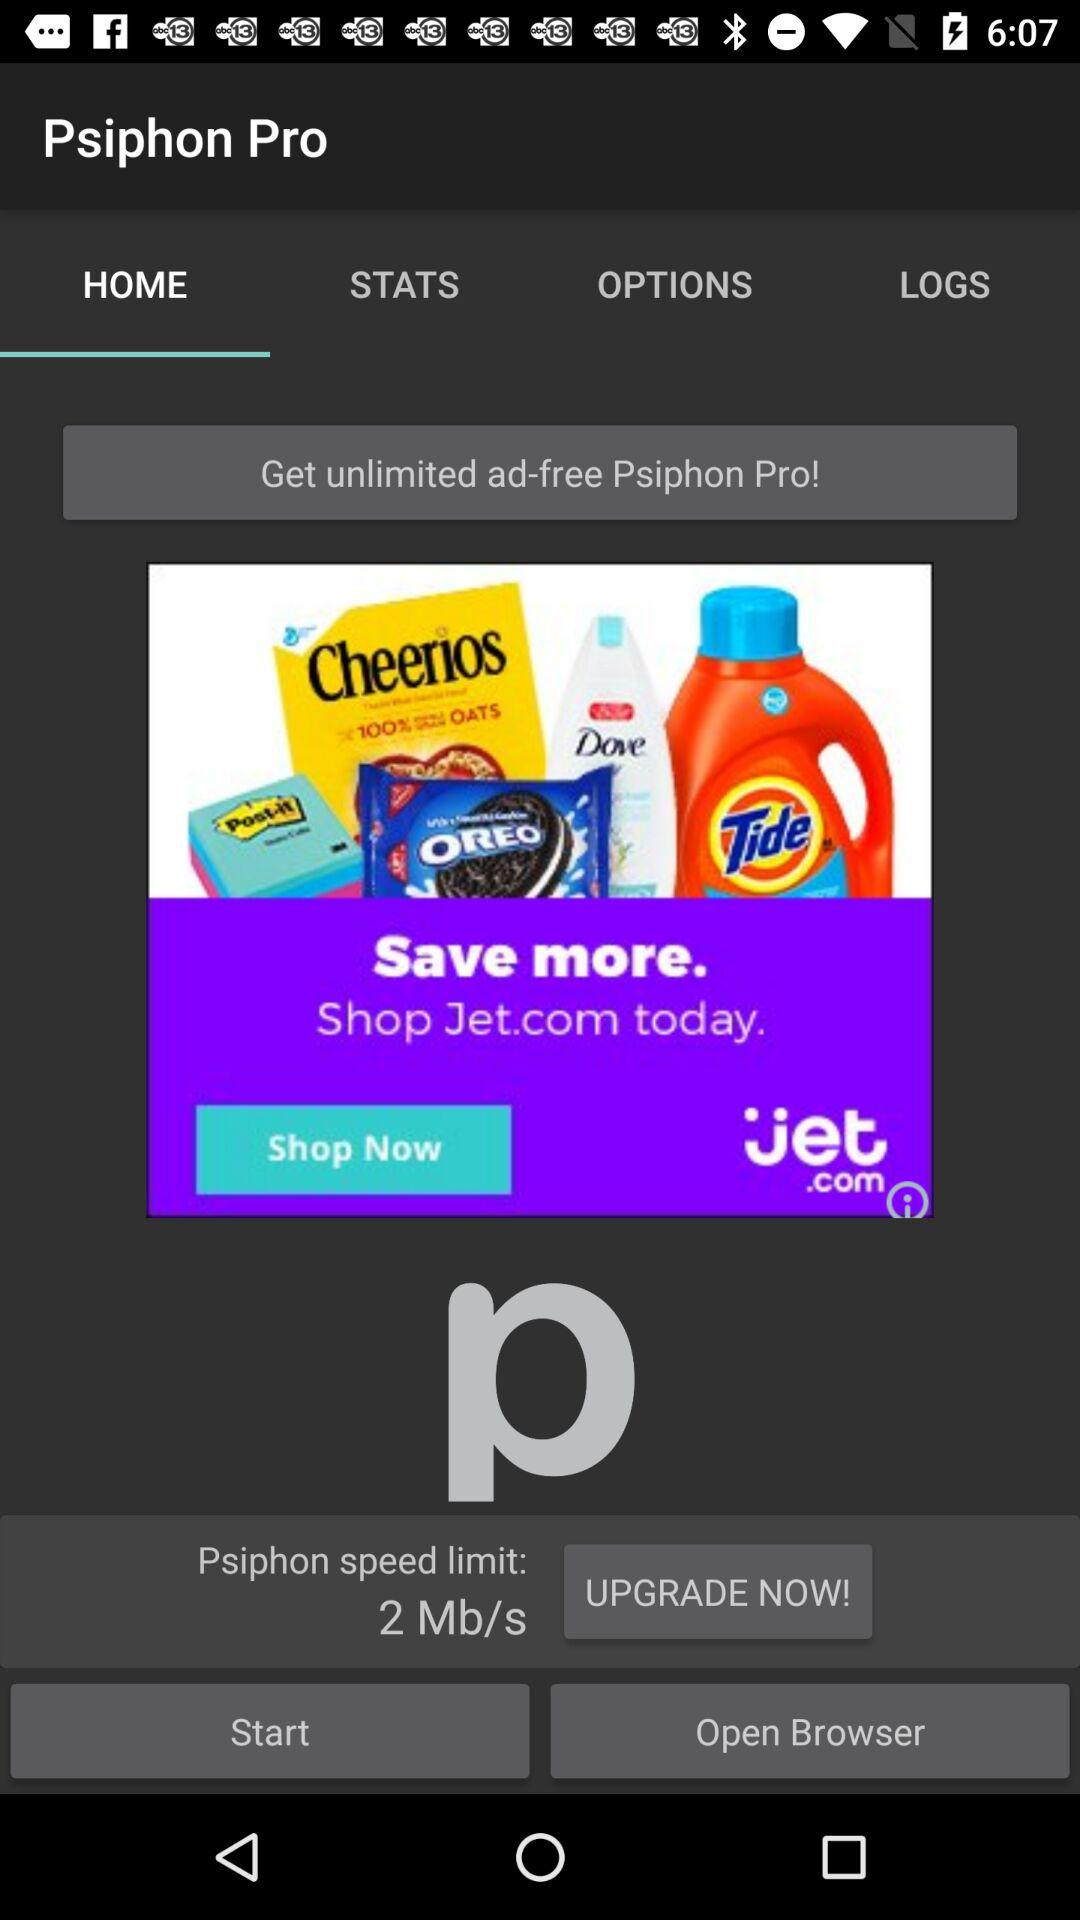What is the "Psiphon speed limit"? The "Psiphon speed limit" is 2 Mb/s. 